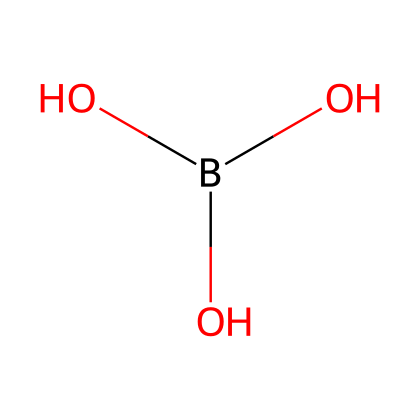What is the name of this chemical? The SMILES representation corresponds to boric acid, which consists of boron, hydrogen, and oxygen. Each atom's connectivity in the SMILES points to boron being at the center, surrounded by hydroxyl groups.
Answer: boric acid How many oxygen atoms are present in this chemical? By analyzing the SMILES, there are three oxygen atoms connected to the boron atom, indicating that the chemical structure contains three distinct oxygen atoms.
Answer: three What type of bond connects boron to oxygen in this chemical? The structure indicates that boron is bonded to oxygen through covalent bonds, as boric acid typically involves sharing electron pairs between boron and oxygen atoms, a characteristic feature of covalent bonding.
Answer: covalent What is the functional group present in this chemical? The presence of -OH (hydroxyl groups) in the structure identifies the hydroxyl functional group. There are three -OH groups designated in the SMILES, signifying that this chemical contains these functional groups.
Answer: hydroxyl Is boric acid classified as a Lewis acid? Boric acid can accept electron pairs due to the electron-deficient nature of the boron atom, which qualifies it as a Lewis acid according to Lewis acid-base theory.
Answer: yes 